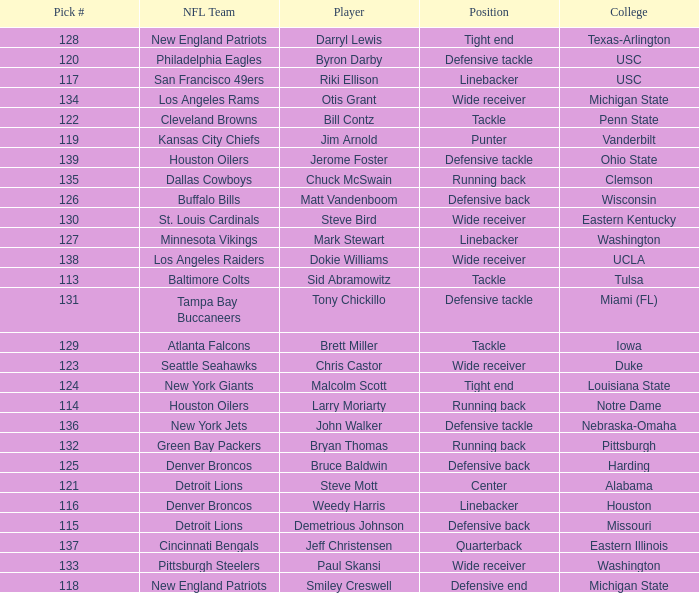What was bruce baldwin's pick #? 125.0. 